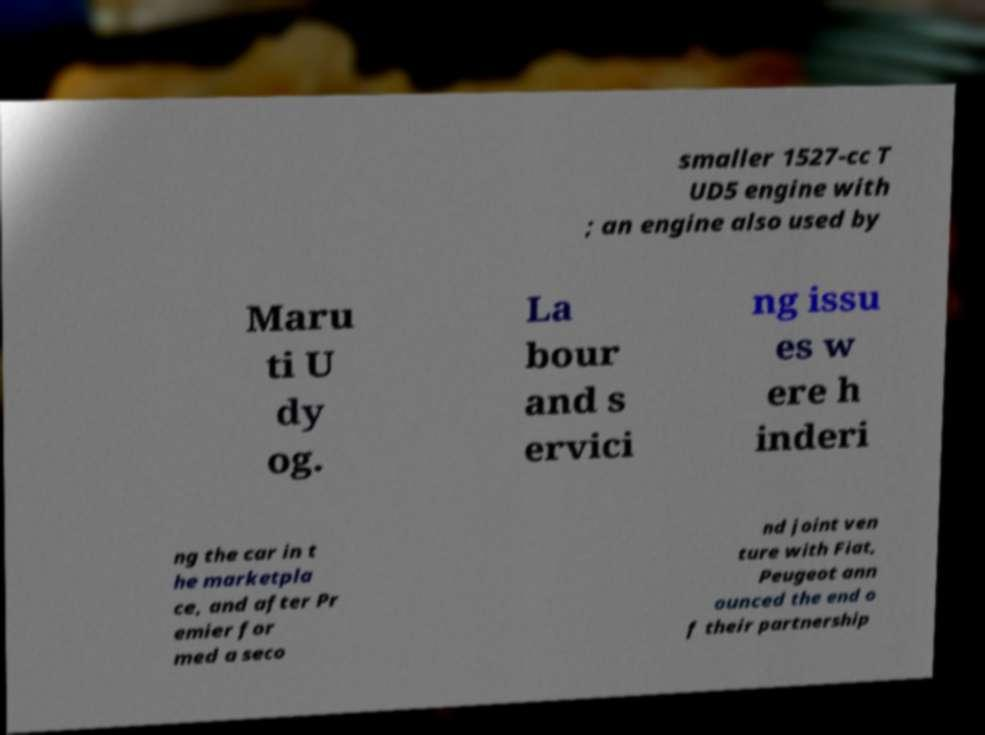What messages or text are displayed in this image? I need them in a readable, typed format. smaller 1527-cc T UD5 engine with ; an engine also used by Maru ti U dy og. La bour and s ervici ng issu es w ere h inderi ng the car in t he marketpla ce, and after Pr emier for med a seco nd joint ven ture with Fiat, Peugeot ann ounced the end o f their partnership 